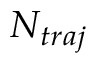Convert formula to latex. <formula><loc_0><loc_0><loc_500><loc_500>N _ { t r a j }</formula> 